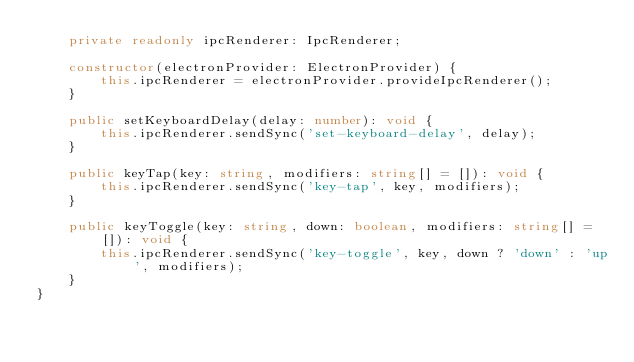<code> <loc_0><loc_0><loc_500><loc_500><_TypeScript_>    private readonly ipcRenderer: IpcRenderer;

    constructor(electronProvider: ElectronProvider) {
        this.ipcRenderer = electronProvider.provideIpcRenderer();
    }

    public setKeyboardDelay(delay: number): void {
        this.ipcRenderer.sendSync('set-keyboard-delay', delay);
    }

    public keyTap(key: string, modifiers: string[] = []): void {
        this.ipcRenderer.sendSync('key-tap', key, modifiers);
    }

    public keyToggle(key: string, down: boolean, modifiers: string[] = []): void {
        this.ipcRenderer.sendSync('key-toggle', key, down ? 'down' : 'up', modifiers);
    }
}
</code> 